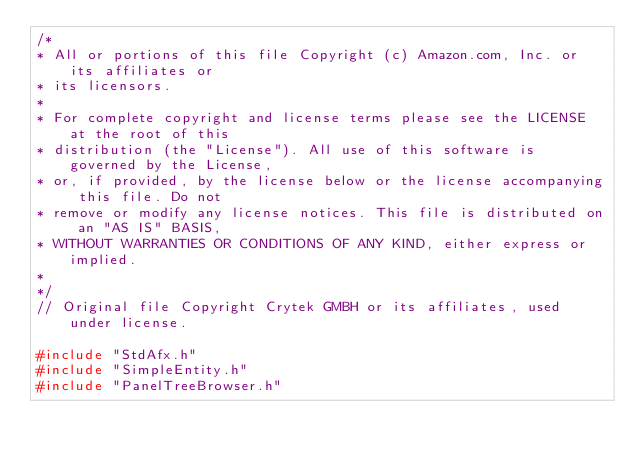Convert code to text. <code><loc_0><loc_0><loc_500><loc_500><_C++_>/*
* All or portions of this file Copyright (c) Amazon.com, Inc. or its affiliates or
* its licensors.
*
* For complete copyright and license terms please see the LICENSE at the root of this
* distribution (the "License"). All use of this software is governed by the License,
* or, if provided, by the license below or the license accompanying this file. Do not
* remove or modify any license notices. This file is distributed on an "AS IS" BASIS,
* WITHOUT WARRANTIES OR CONDITIONS OF ANY KIND, either express or implied.
*
*/
// Original file Copyright Crytek GMBH or its affiliates, used under license.

#include "StdAfx.h"
#include "SimpleEntity.h"
#include "PanelTreeBrowser.h"</code> 